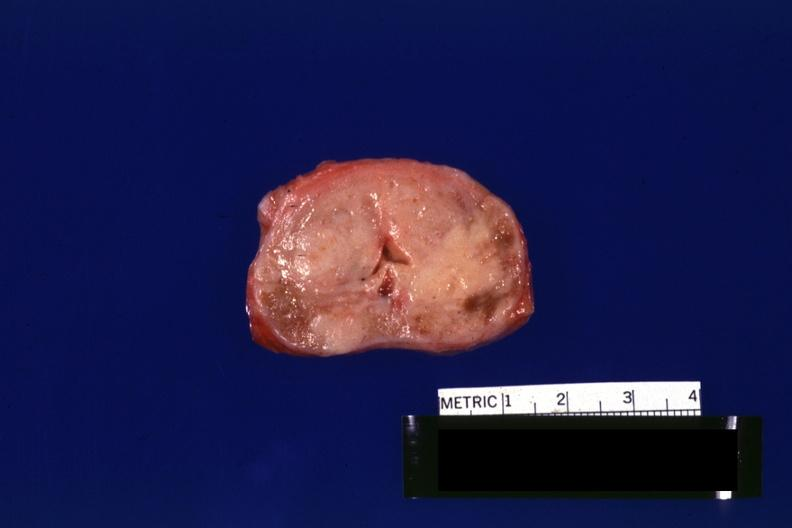what is present?
Answer the question using a single word or phrase. Adenocarcinoma 